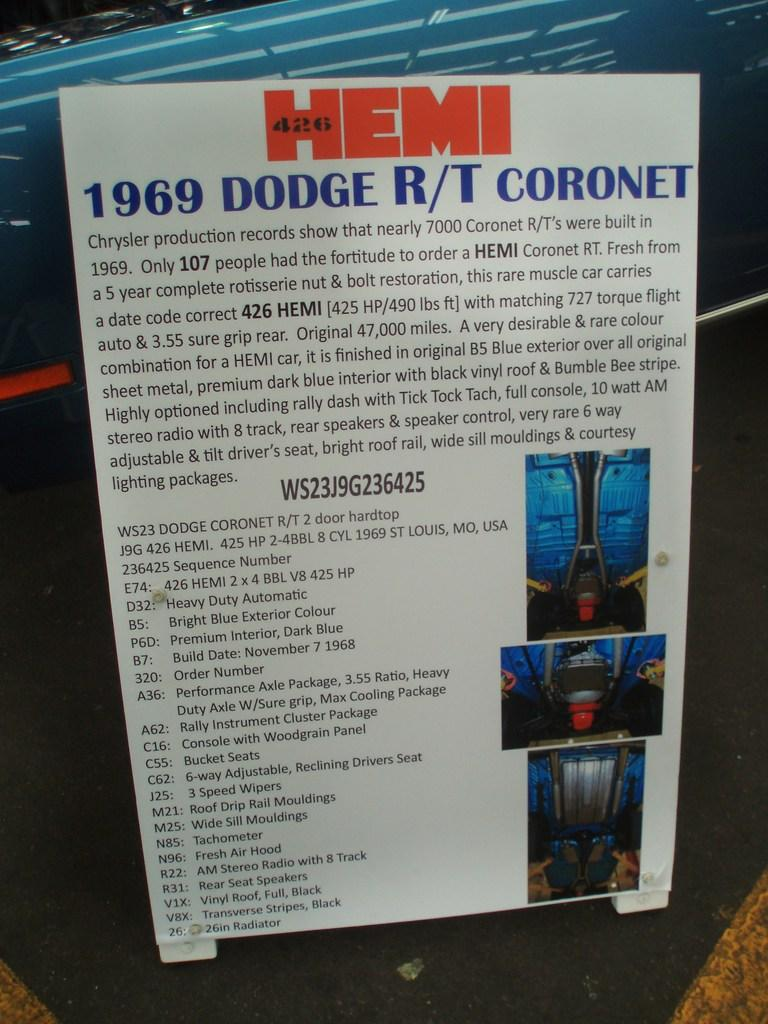<image>
Give a short and clear explanation of the subsequent image. a large poster that says 'hemi' on it 